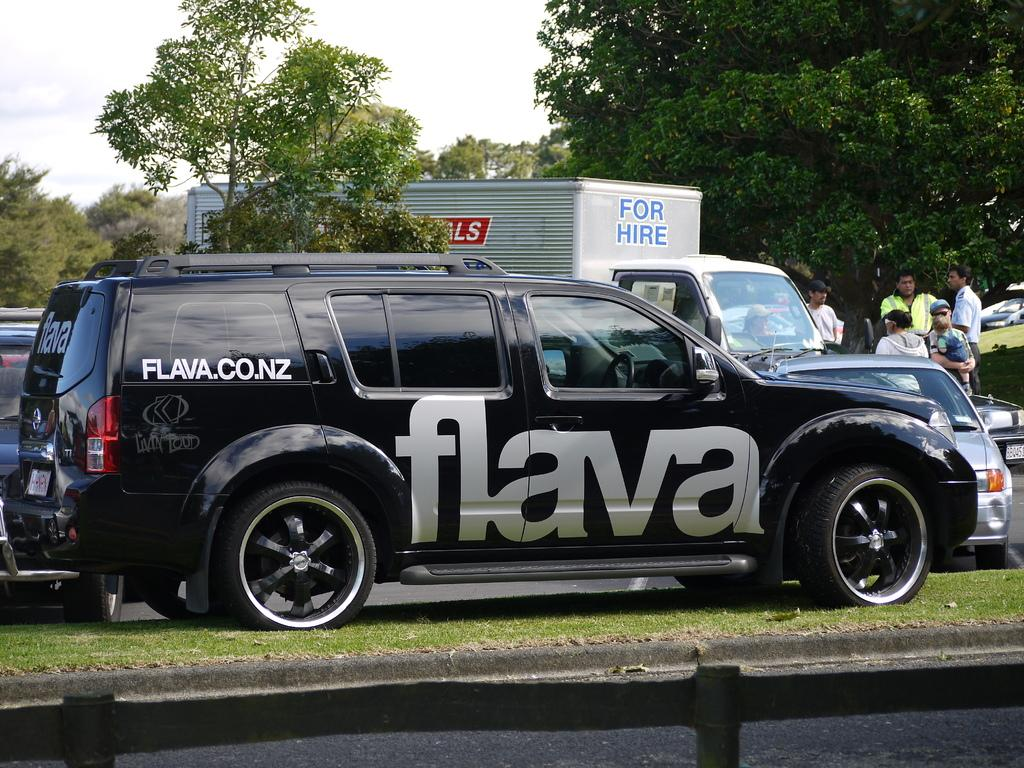What is the main subject in the center of the image? There is a vehicle in the center of the image. Where is the vehicle located? The vehicle is on the grass. What can be seen in the background of the image? There are vehicles, trees, persons, and the sky visible in the background of the image. What is the condition of the sky in the image? The sky is visible in the background of the image, and there are clouds present. What is at the bottom of the image? There is a road at the bottom of the image. What type of cork can be seen floating in the sky in the image? There is no cork present in the image, and therefore no such object can be observed in the sky. 